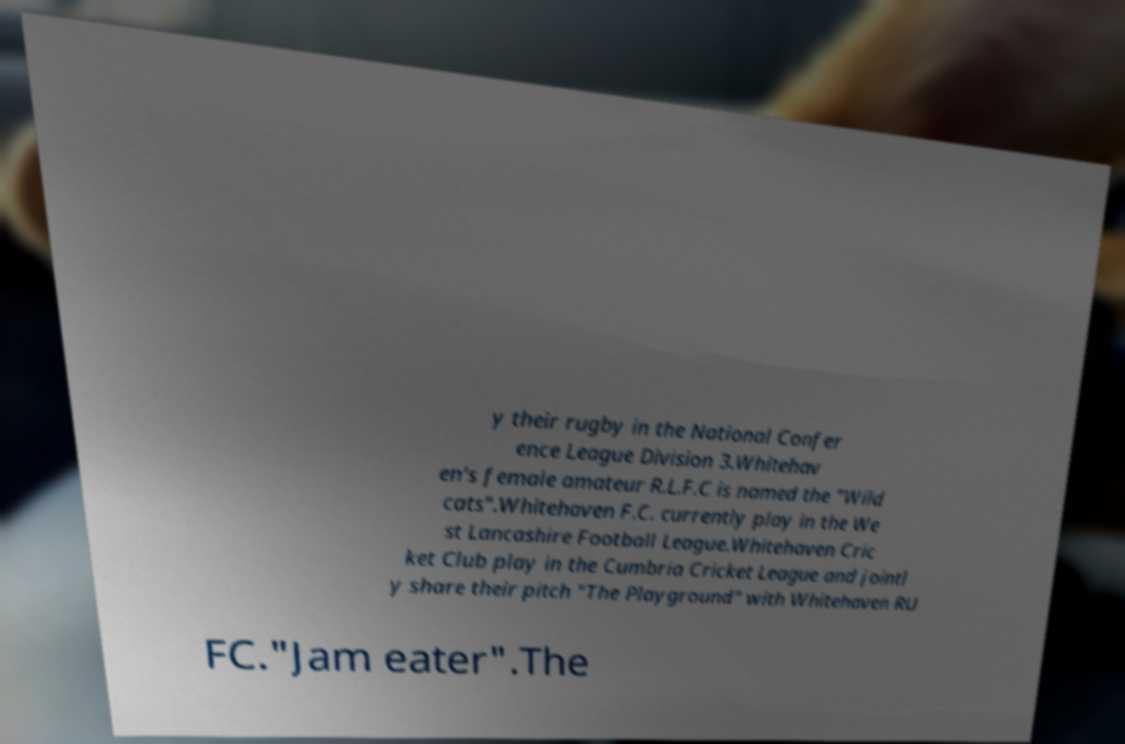I need the written content from this picture converted into text. Can you do that? y their rugby in the National Confer ence League Division 3.Whitehav en's female amateur R.L.F.C is named the "Wild cats".Whitehaven F.C. currently play in the We st Lancashire Football League.Whitehaven Cric ket Club play in the Cumbria Cricket League and jointl y share their pitch "The Playground" with Whitehaven RU FC."Jam eater".The 